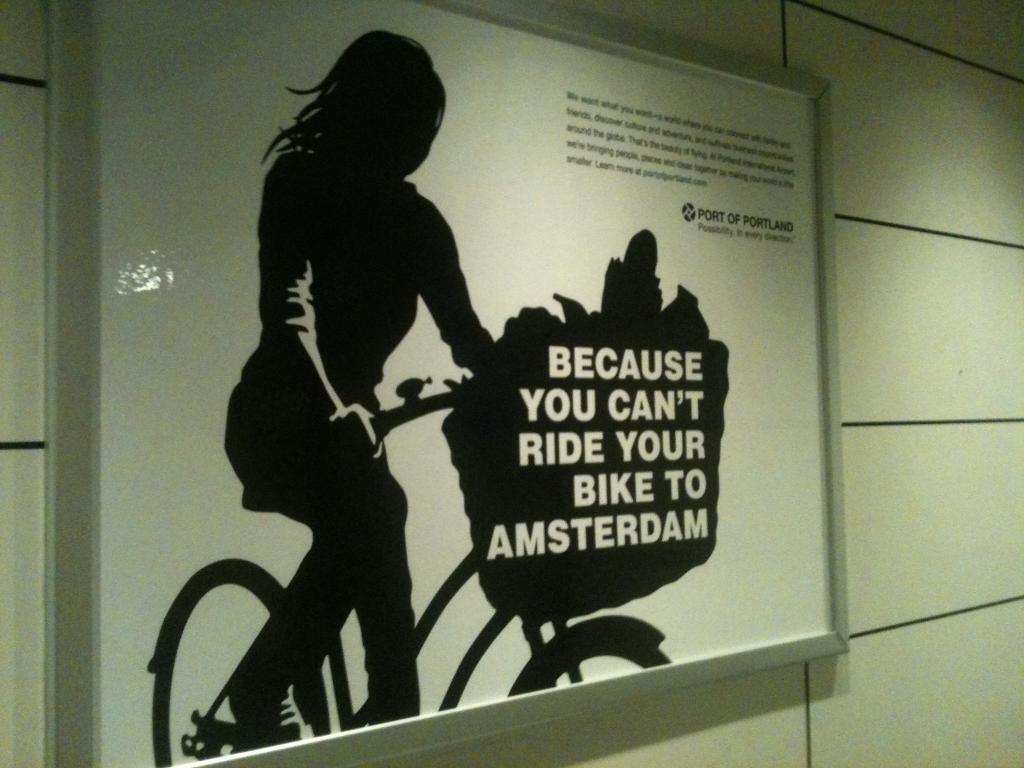How would you summarize this image in a sentence or two? In this image in the center there is one board, on the board there is text. And one girl is sitting on a cycle, and in the background there is wall. 